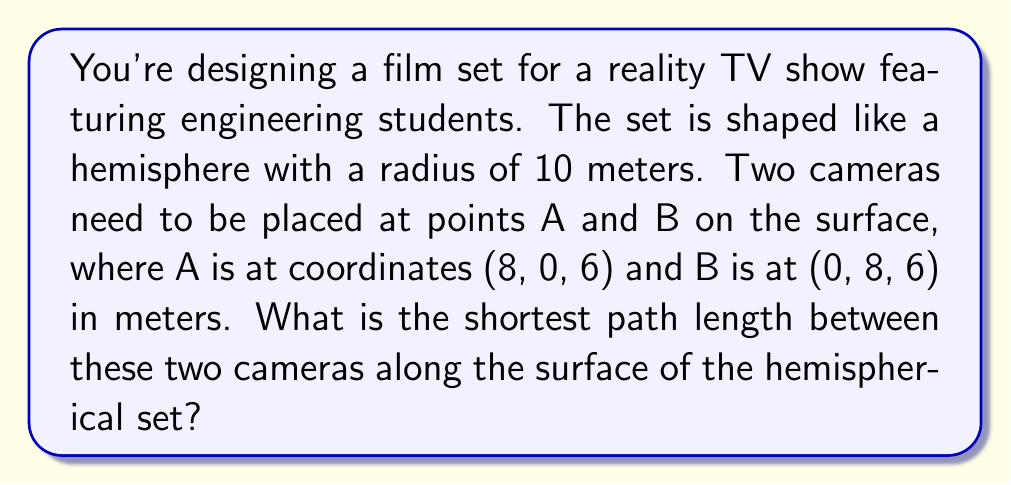Help me with this question. Let's approach this step-by-step:

1) In a hemisphere, the shortest path between two points is along a great circle arc. This is analogous to the geodesic on a sphere.

2) To find the length of this arc, we need to:
   a) Calculate the central angle between the two points
   b) Use this angle to determine the arc length

3) The central angle θ can be found using the dot product formula:

   $$\cos \theta = \frac{\vec{OA} \cdot \vec{OB}}{|\vec{OA}||\vec{OB}|}$$

   Where O is the center of the hemisphere (0, 0, 0).

4) Calculate the vectors:
   $$\vec{OA} = (8, 0, 6)$$
   $$\vec{OB} = (0, 8, 6)$$

5) Calculate the dot product:
   $$\vec{OA} \cdot \vec{OB} = 8(0) + 0(8) + 6(6) = 36$$

6) Calculate the magnitudes:
   $$|\vec{OA}| = |\vec{OB}| = \sqrt{8^2 + 0^2 + 6^2} = \sqrt{64 + 36} = \sqrt{100} = 10$$

7) Apply the formula:
   $$\cos \theta = \frac{36}{10 \cdot 10} = \frac{36}{100} = 0.36$$

8) Take the inverse cosine:
   $$\theta = \arccos(0.36) \approx 1.2030 \text{ radians}$$

9) The arc length s is given by:
   $$s = r\theta$$
   Where r is the radius of the hemisphere (10 meters).

10) Calculate the arc length:
    $$s = 10 \cdot 1.2030 \approx 12.0300 \text{ meters}$$

Therefore, the shortest path length between the two cameras is approximately 12.0300 meters.
Answer: 12.0300 meters 